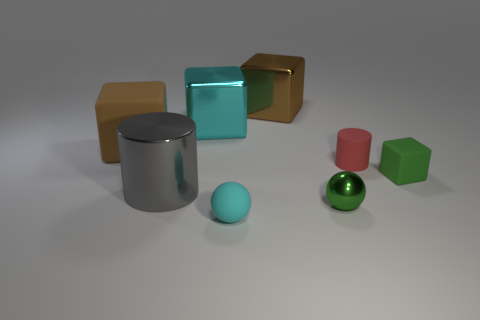What number of other things are the same color as the matte ball?
Your response must be concise. 1. What shape is the big brown rubber object?
Your answer should be compact. Cube. There is a cylinder in front of the rubber cube in front of the brown matte cube; what number of green matte blocks are on the left side of it?
Ensure brevity in your answer.  0. What number of other objects are the same material as the small cylinder?
Provide a succinct answer. 3. There is a cube that is the same size as the green ball; what is it made of?
Make the answer very short. Rubber. Is the color of the big thing that is in front of the green rubber thing the same as the cube that is on the right side of the brown metal block?
Ensure brevity in your answer.  No. Is there another large object that has the same shape as the gray object?
Your response must be concise. No. What shape is the cyan metallic thing that is the same size as the brown rubber cube?
Make the answer very short. Cube. What number of objects have the same color as the matte cylinder?
Your answer should be compact. 0. There is a cyan thing on the right side of the cyan shiny block; what size is it?
Offer a terse response. Small. 